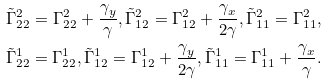Convert formula to latex. <formula><loc_0><loc_0><loc_500><loc_500>\tilde { \Gamma } ^ { 2 } _ { 2 2 } = \Gamma ^ { 2 } _ { 2 2 } + \frac { \gamma _ { y } } { \gamma } , \tilde { \Gamma } ^ { 2 } _ { 1 2 } = \Gamma ^ { 2 } _ { 1 2 } + \frac { \gamma _ { x } } { 2 \gamma } , \tilde { \Gamma } ^ { 2 } _ { 1 1 } = \Gamma ^ { 2 } _ { 1 1 } , \\ \tilde { \Gamma } ^ { 1 } _ { 2 2 } = \Gamma ^ { 1 } _ { 2 2 } , \tilde { \Gamma } ^ { 1 } _ { 1 2 } = \Gamma ^ { 1 } _ { 1 2 } + \frac { \gamma _ { y } } { 2 \gamma } , \tilde { \Gamma } ^ { 1 } _ { 1 1 } = \Gamma ^ { 1 } _ { 1 1 } + \frac { \gamma _ { x } } { \gamma } .</formula> 